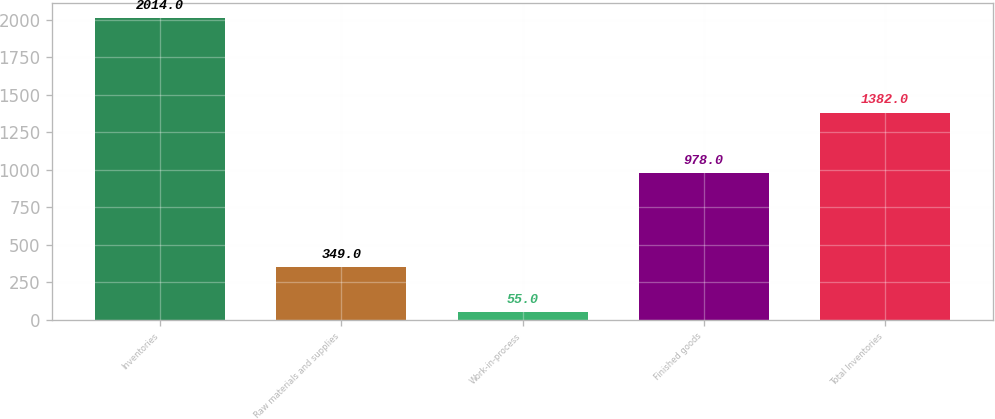<chart> <loc_0><loc_0><loc_500><loc_500><bar_chart><fcel>Inventories<fcel>Raw materials and supplies<fcel>Work-in-process<fcel>Finished goods<fcel>Total Inventories<nl><fcel>2014<fcel>349<fcel>55<fcel>978<fcel>1382<nl></chart> 